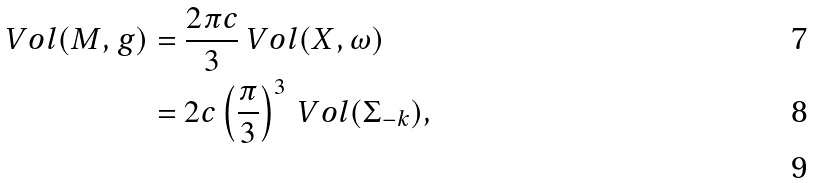Convert formula to latex. <formula><loc_0><loc_0><loc_500><loc_500>\ V o l ( M , g ) & = \frac { 2 \pi c } { 3 } \ V o l ( X , \omega ) \\ & = 2 c \left ( \frac { \pi } { 3 } \right ) ^ { 3 } \ V o l ( \Sigma _ { - k } ) , \\</formula> 